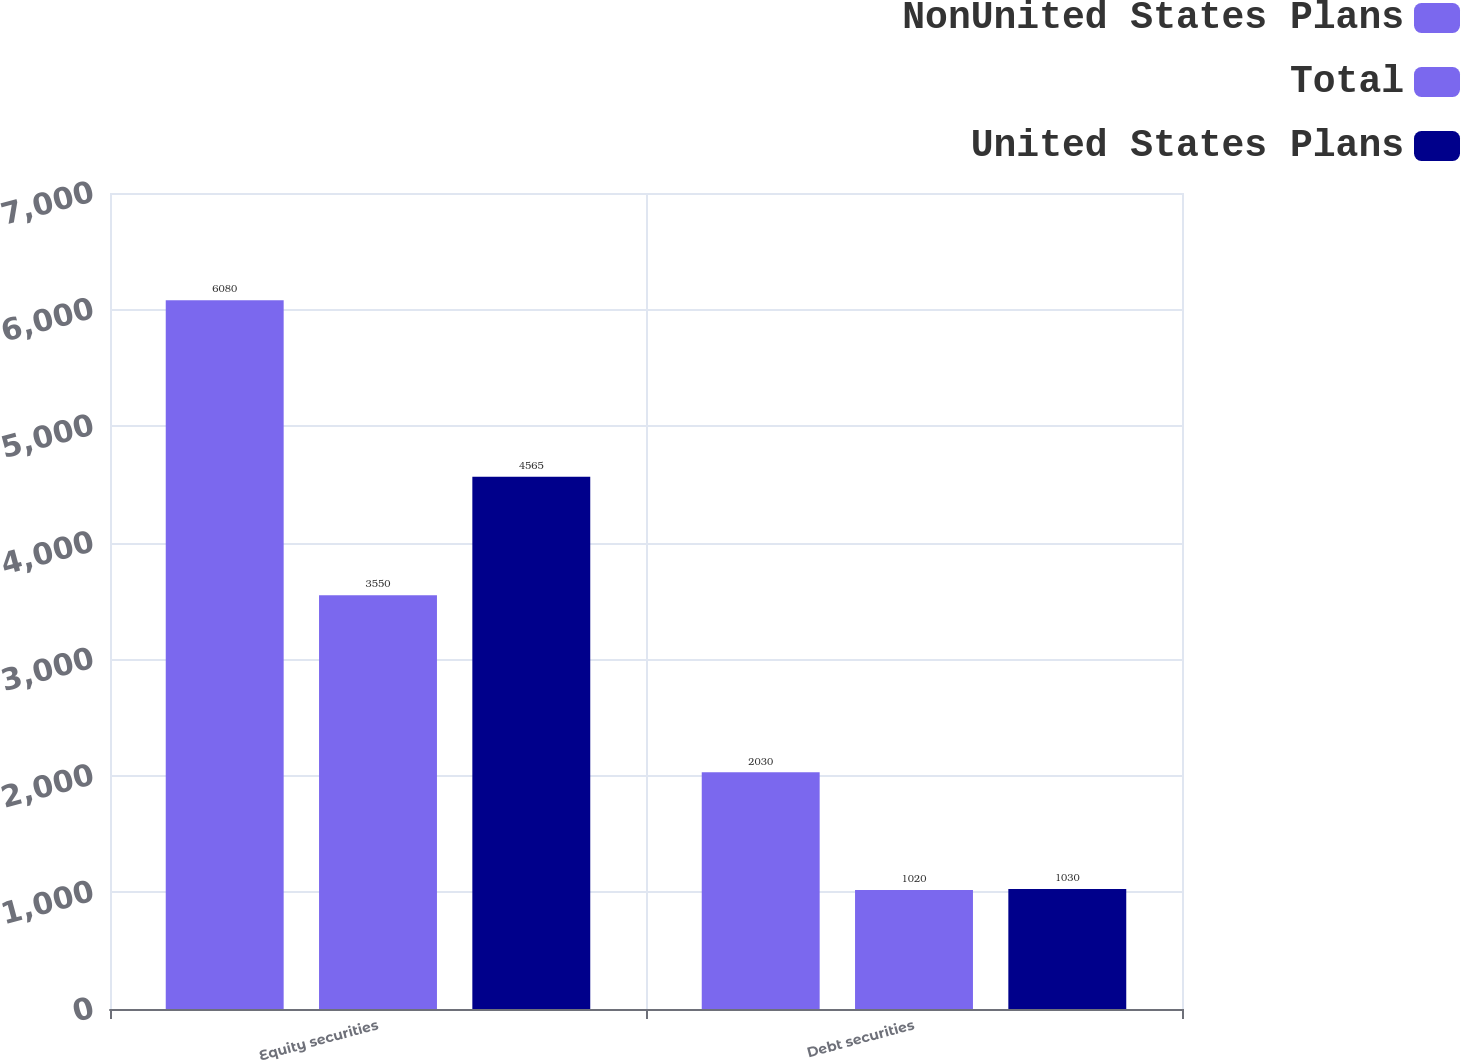<chart> <loc_0><loc_0><loc_500><loc_500><stacked_bar_chart><ecel><fcel>Equity securities<fcel>Debt securities<nl><fcel>NonUnited States Plans<fcel>6080<fcel>2030<nl><fcel>Total<fcel>3550<fcel>1020<nl><fcel>United States Plans<fcel>4565<fcel>1030<nl></chart> 